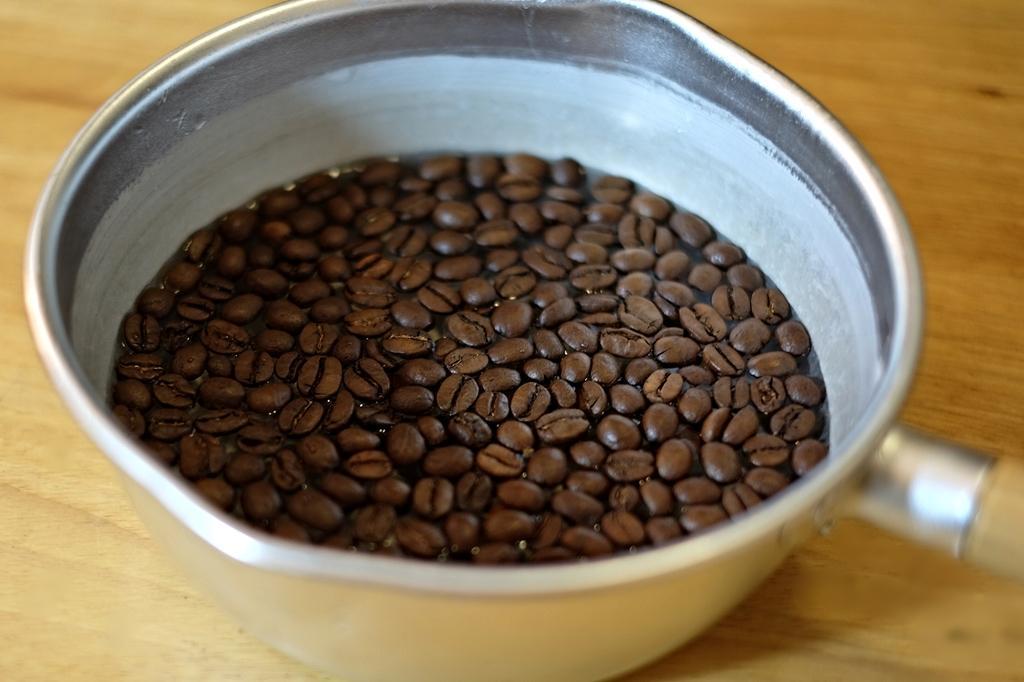Please provide a concise description of this image. In this image we can see the coffee beans in a bowl which is placed on the wooden surface. 